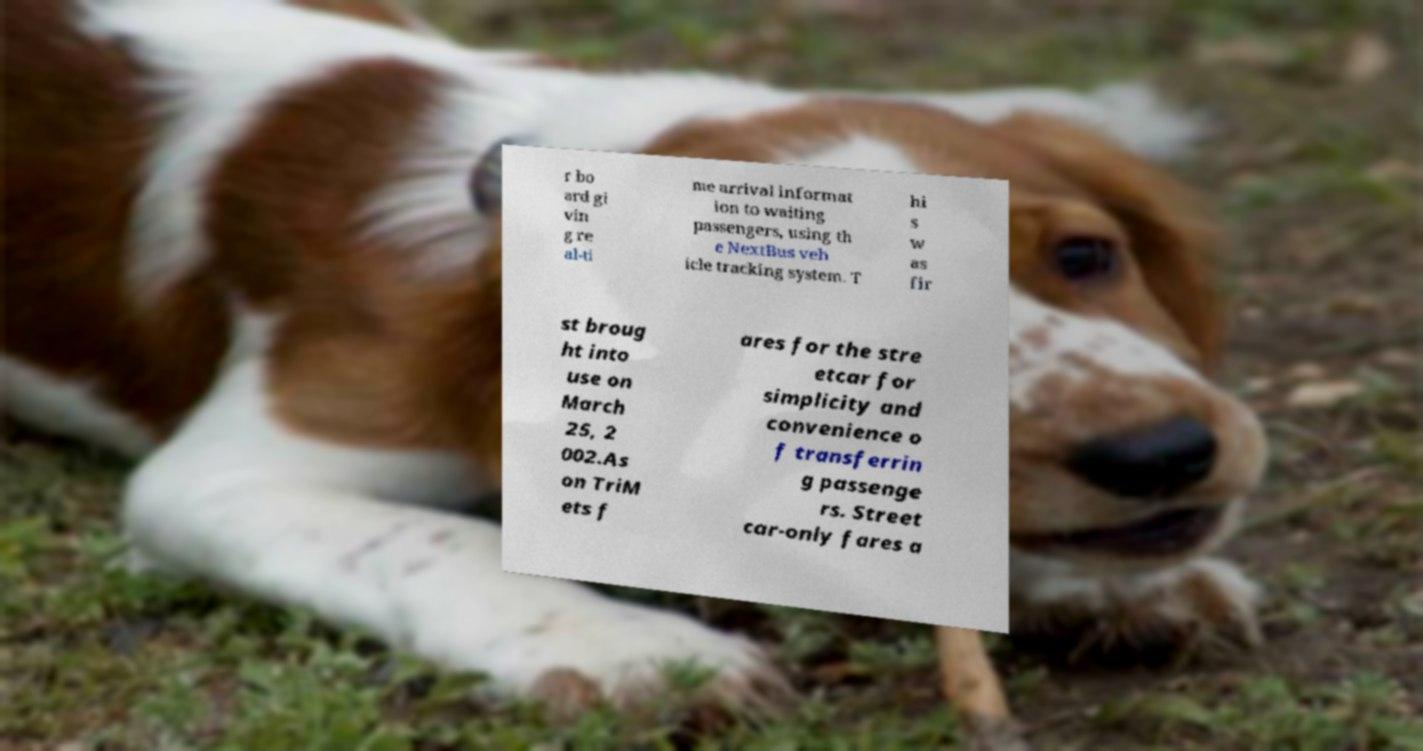What messages or text are displayed in this image? I need them in a readable, typed format. r bo ard gi vin g re al-ti me arrival informat ion to waiting passengers, using th e NextBus veh icle tracking system. T hi s w as fir st broug ht into use on March 25, 2 002.As on TriM ets f ares for the stre etcar for simplicity and convenience o f transferrin g passenge rs. Street car-only fares a 